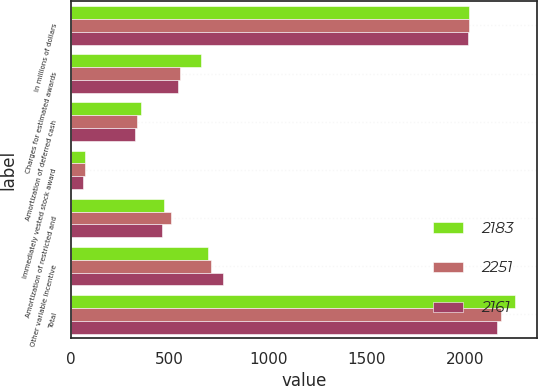Convert chart to OTSL. <chart><loc_0><loc_0><loc_500><loc_500><stacked_bar_chart><ecel><fcel>In millions of dollars<fcel>Charges for estimated awards<fcel>Amortization of deferred cash<fcel>Immediately vested stock award<fcel>Amortization of restricted and<fcel>Other variable incentive<fcel>Total<nl><fcel>2183<fcel>2017<fcel>659<fcel>354<fcel>70<fcel>474<fcel>694<fcel>2251<nl><fcel>2251<fcel>2016<fcel>555<fcel>336<fcel>73<fcel>509<fcel>710<fcel>2183<nl><fcel>2161<fcel>2015<fcel>541<fcel>325<fcel>61<fcel>461<fcel>773<fcel>2161<nl></chart> 